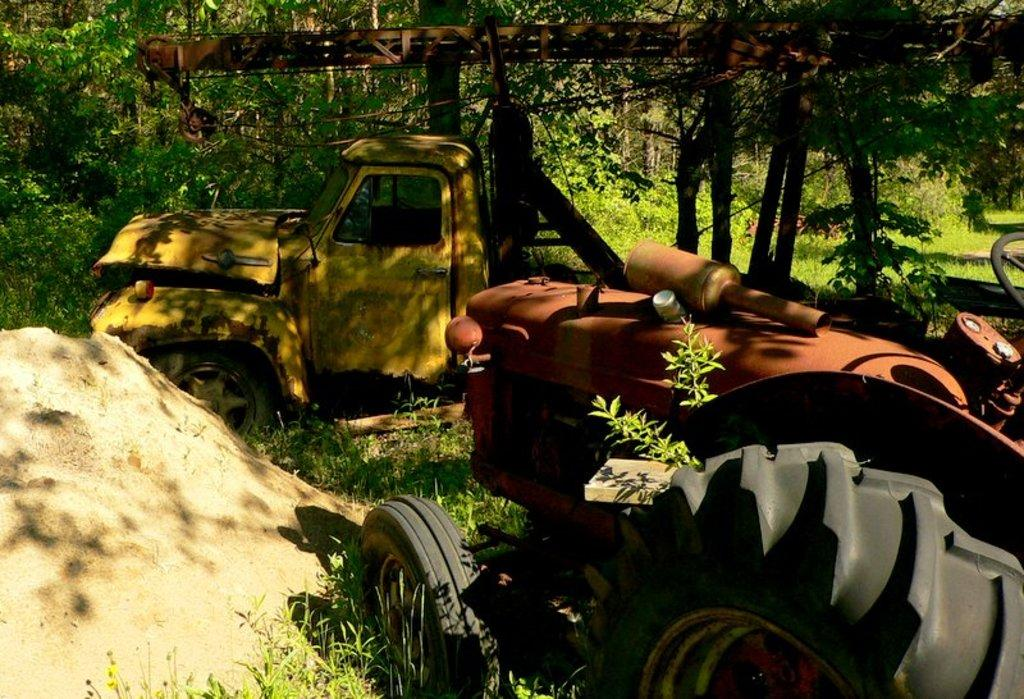What can be seen in the image that appears to be out of use? There are two abandoned vehicles in the image. What is present on the ground in the image? There is a crane on the ground in the image. What type of terrain is visible on the left side of the image? There is sand on the left side of the image. What can be seen in the distance in the image? There are trees in the background of the image. How many friends are sitting on the donkey in the image? There is no donkey present in the image, so it is not possible to answer that question. 